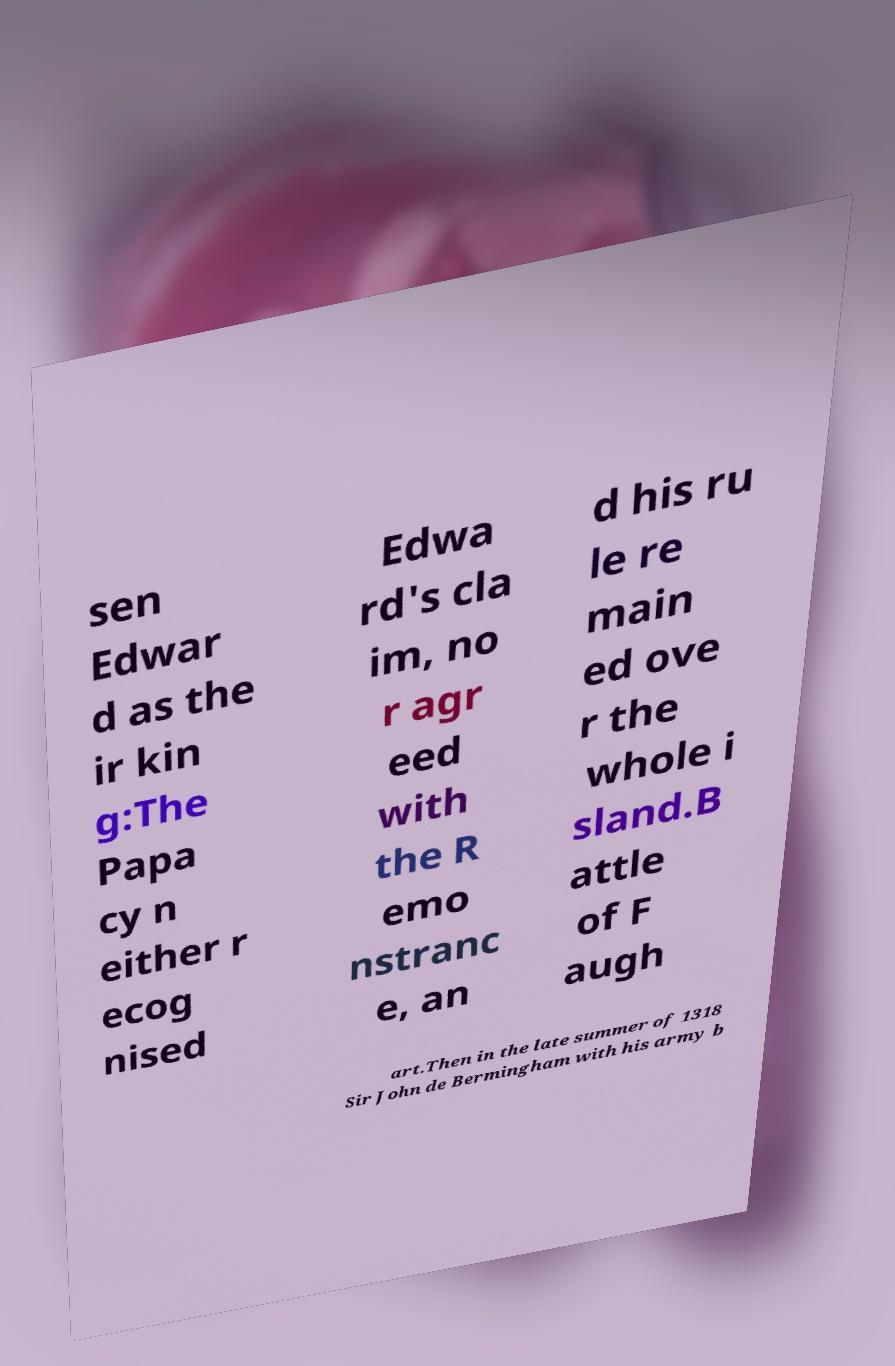Could you assist in decoding the text presented in this image and type it out clearly? sen Edwar d as the ir kin g:The Papa cy n either r ecog nised Edwa rd's cla im, no r agr eed with the R emo nstranc e, an d his ru le re main ed ove r the whole i sland.B attle of F augh art.Then in the late summer of 1318 Sir John de Bermingham with his army b 